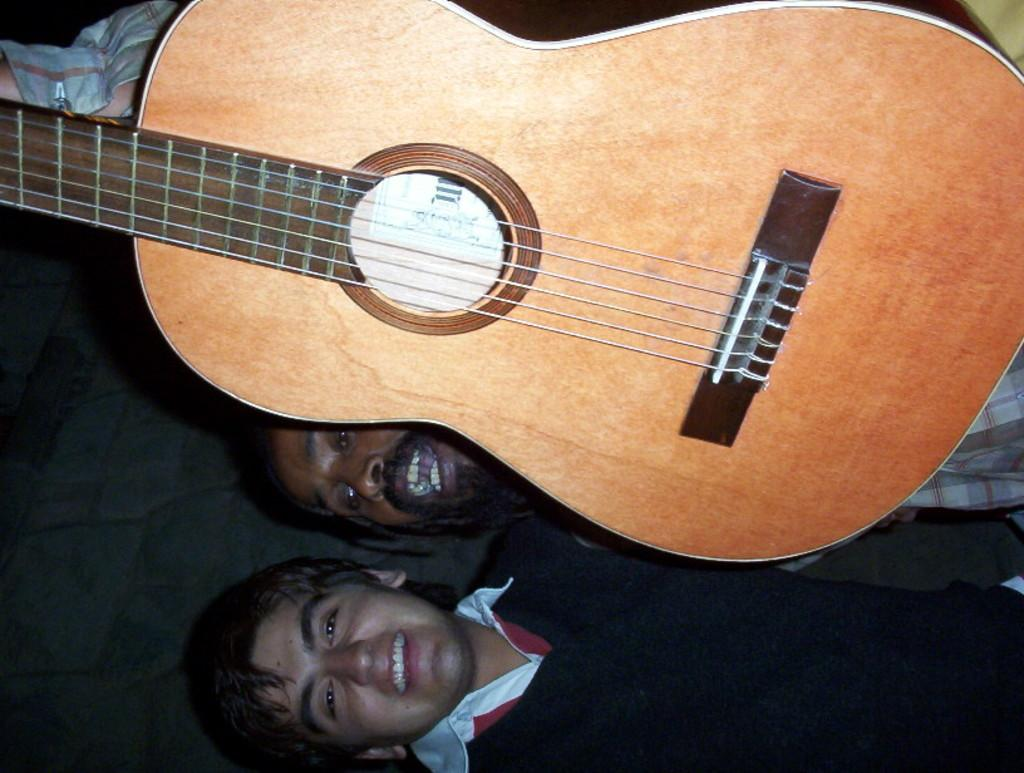What is the main subject of the image? The main subject of the image is a guy holding a guitar. How is the guy holding the guitar? The guy is holding the guitar with one hand. Can you describe another person in the image? Yes, there is another guy wearing a black shirt in the image. Where is the monkey playing with a calculator in the image? There is no monkey or calculator present in the image. 